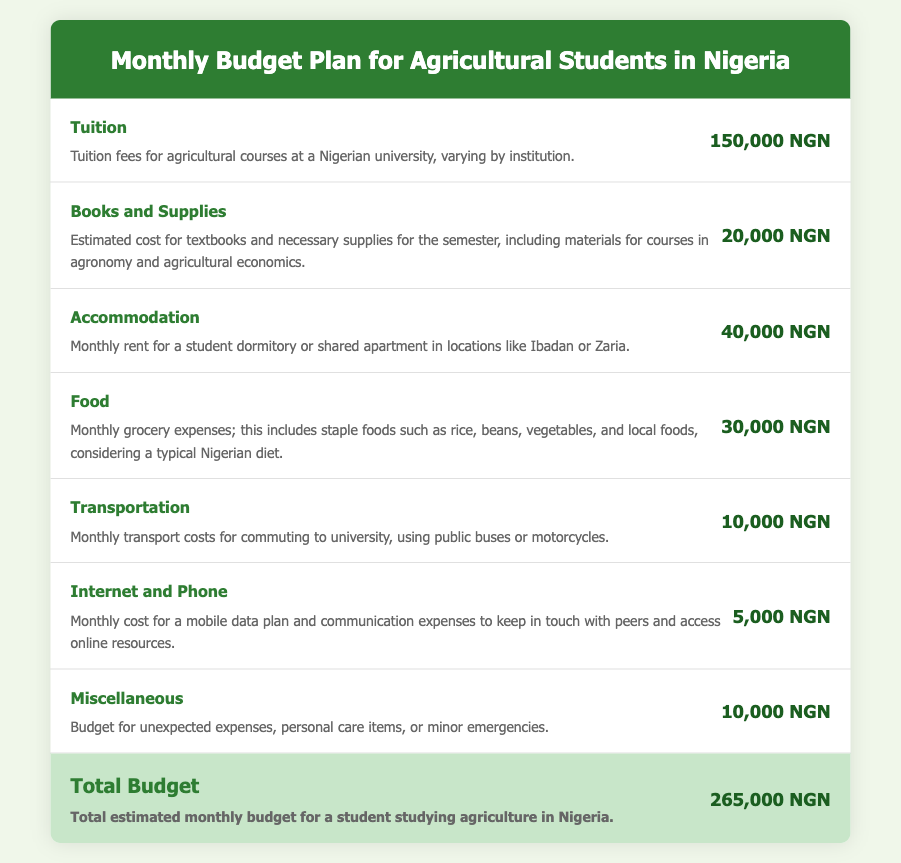What is the tuition fee? The tuition fee listed for agricultural courses at a Nigerian university is 150,000 NGN.
Answer: 150,000 NGN What is the estimated cost for books and supplies? The document states that the estimated cost for textbooks and necessary supplies for the semester is 20,000 NGN.
Answer: 20,000 NGN How much is the monthly accommodation expense? The monthly rent for a student dormitory or shared apartment is indicated to be 40,000 NGN.
Answer: 40,000 NGN What is the total estimated monthly budget? The total estimated monthly budget for a student studying agriculture in Nigeria is calculated as 265,000 NGN.
Answer: 265,000 NGN What are the transportation costs for commuting? The document specifies the monthly transport costs for commuting to university as 10,000 NGN.
Answer: 10,000 NGN What is included in the food budget? The monthly grocery expenses include staple foods such as rice, beans, and vegetables.
Answer: Staple foods How much is budgeted for internet and phone? The document states the monthly cost for a mobile data plan and communication expenses is 5,000 NGN.
Answer: 5,000 NGN What category does the miscellaneous budget cover? The miscellaneous budget covers unexpected expenses, personal care items, or minor emergencies.
Answer: Unexpected expenses How much is allocated for food expenses? The monthly grocery expenses listed in the document amount to 30,000 NGN.
Answer: 30,000 NGN 